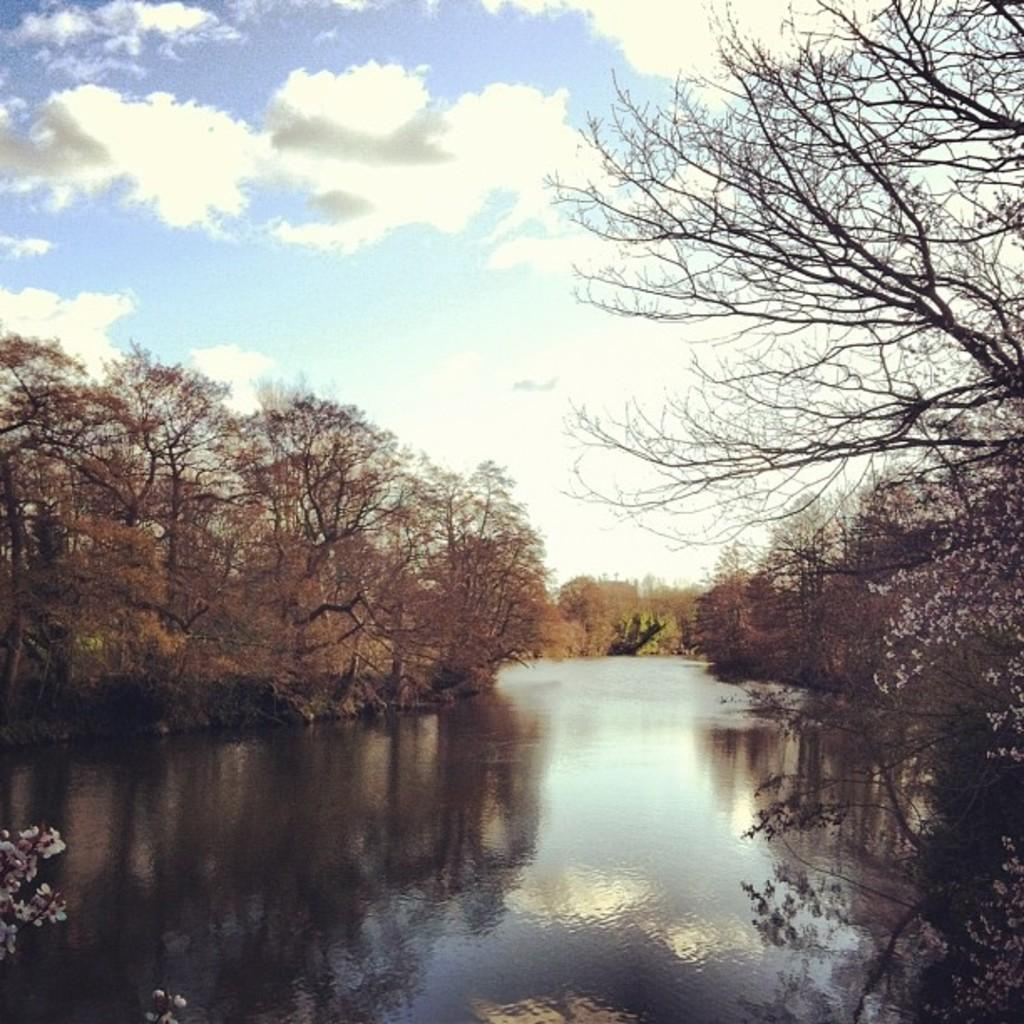What is located in the center of the image? There is water in the center of the image. What type of vegetation can be seen on both sides of the image? There are trees on both sides of the image. What is visible at the top of the image? The sky is visible at the top of the image. What can be seen in the sky? Clouds are present in the sky. What type of drug is being sold by the scarecrow in the image? There is no scarecrow or drug present in the image. What sound does the whistle make in the image? There is no whistle present in the image. 